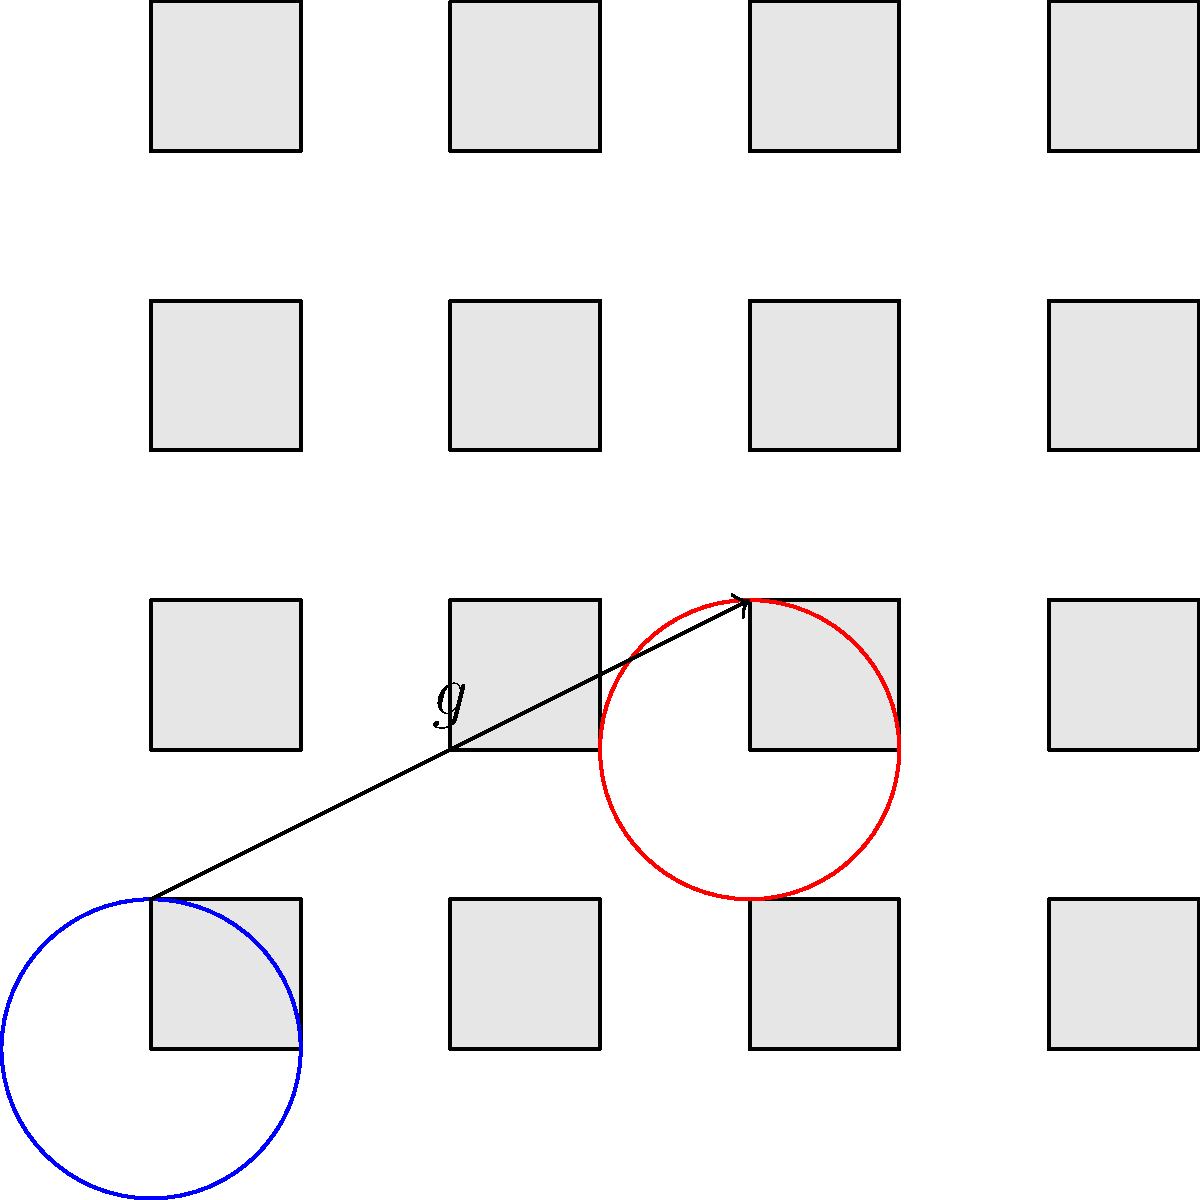In the Arabesque pattern shown above, a glide reflection $g$ transforms the blue circle to the red circle. If we consider the side length of each square to be 1 unit, what is the magnitude of the translation vector in this glide reflection? To determine the magnitude of the translation vector in this glide reflection, we need to follow these steps:

1) First, let's understand what a glide reflection is. It's a combination of a reflection and a translation parallel to the line of reflection.

2) In this pattern, we can see that the blue circle is transformed to the red circle.

3) The line of reflection is the line that passes through the midpoint of the line segment connecting the centers of the blue and red circles, and is parallel to the translation.

4) We can see that the horizontal displacement is 2 units (from the left edge to the third column).

5) The vertical displacement is 1 unit (from the bottom row to the second row).

6) The translation vector is therefore (2, 1).

7) To find the magnitude of this vector, we use the Pythagorean theorem:

   $$\text{magnitude} = \sqrt{2^2 + 1^2} = \sqrt{4 + 1} = \sqrt{5}$$

Thus, the magnitude of the translation vector in this glide reflection is $\sqrt{5}$ units.
Answer: $\sqrt{5}$ units 